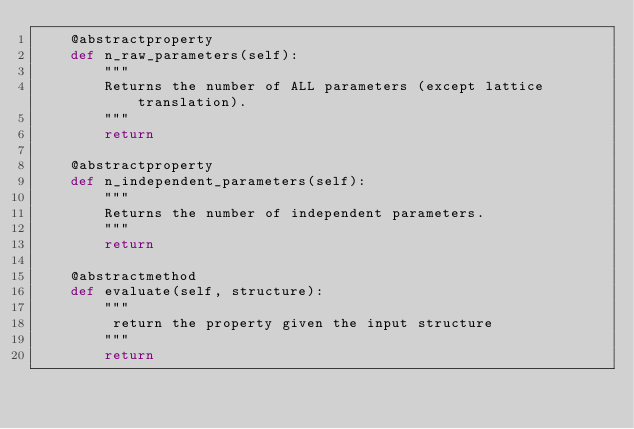<code> <loc_0><loc_0><loc_500><loc_500><_Python_>    @abstractproperty
    def n_raw_parameters(self):
        """
        Returns the number of ALL parameters (except lattice translation).
        """
        return

    @abstractproperty
    def n_independent_parameters(self):
        """
        Returns the number of independent parameters.
        """
        return

    @abstractmethod
    def evaluate(self, structure):
        """
         return the property given the input structure
        """
        return
</code> 